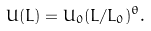Convert formula to latex. <formula><loc_0><loc_0><loc_500><loc_500>U ( L ) = U _ { 0 } ( L / L _ { 0 } ) ^ { \theta } .</formula> 